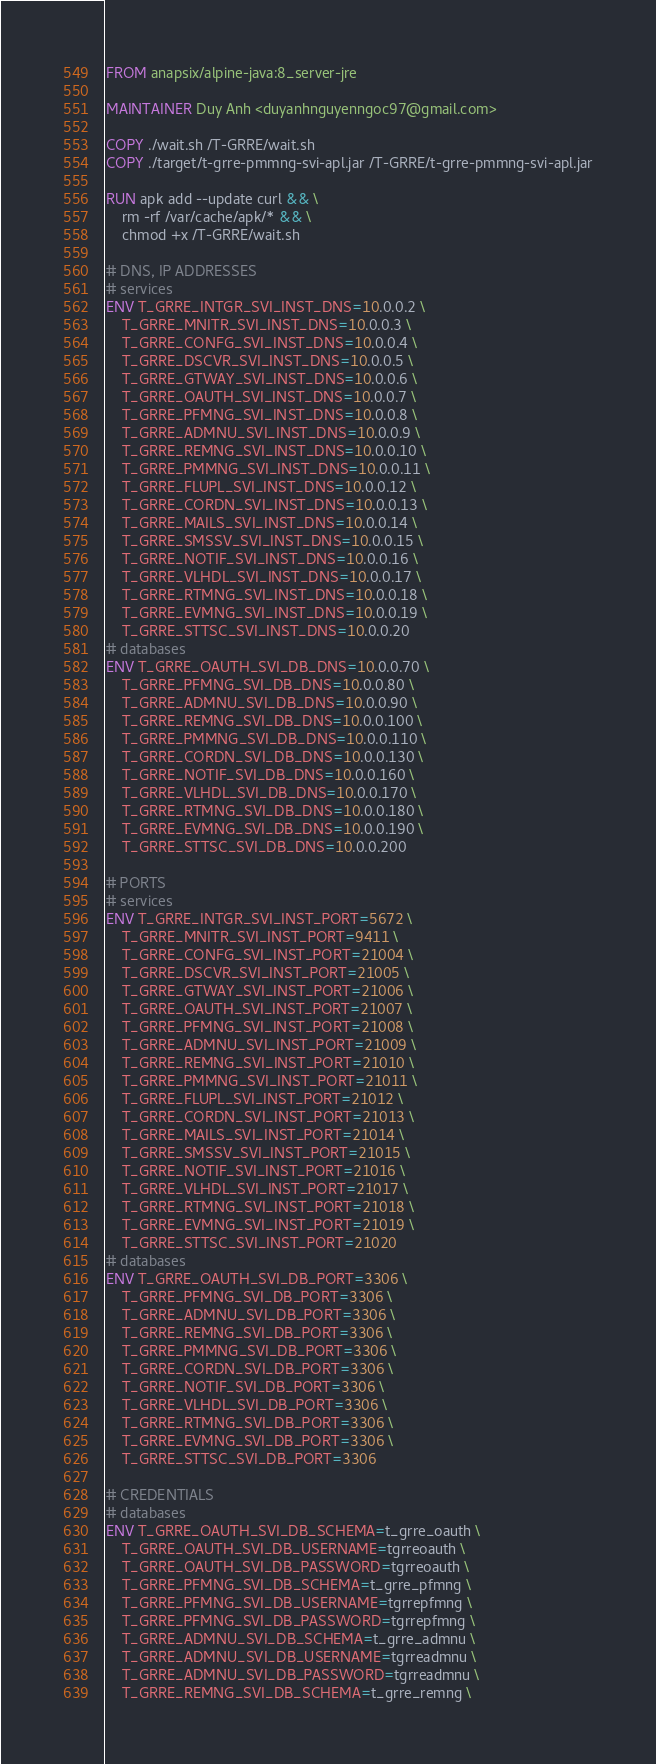<code> <loc_0><loc_0><loc_500><loc_500><_Dockerfile_>FROM anapsix/alpine-java:8_server-jre

MAINTAINER Duy Anh <duyanhnguyenngoc97@gmail.com>

COPY ./wait.sh /T-GRRE/wait.sh
COPY ./target/t-grre-pmmng-svi-apl.jar /T-GRRE/t-grre-pmmng-svi-apl.jar

RUN apk add --update curl && \
    rm -rf /var/cache/apk/* && \
    chmod +x /T-GRRE/wait.sh

# DNS, IP ADDRESSES
# services
ENV T_GRRE_INTGR_SVI_INST_DNS=10.0.0.2 \
    T_GRRE_MNITR_SVI_INST_DNS=10.0.0.3 \
    T_GRRE_CONFG_SVI_INST_DNS=10.0.0.4 \
    T_GRRE_DSCVR_SVI_INST_DNS=10.0.0.5 \
    T_GRRE_GTWAY_SVI_INST_DNS=10.0.0.6 \
    T_GRRE_OAUTH_SVI_INST_DNS=10.0.0.7 \
    T_GRRE_PFMNG_SVI_INST_DNS=10.0.0.8 \
    T_GRRE_ADMNU_SVI_INST_DNS=10.0.0.9 \
    T_GRRE_REMNG_SVI_INST_DNS=10.0.0.10 \
    T_GRRE_PMMNG_SVI_INST_DNS=10.0.0.11 \
    T_GRRE_FLUPL_SVI_INST_DNS=10.0.0.12 \
    T_GRRE_CORDN_SVI_INST_DNS=10.0.0.13 \
    T_GRRE_MAILS_SVI_INST_DNS=10.0.0.14 \
    T_GRRE_SMSSV_SVI_INST_DNS=10.0.0.15 \
    T_GRRE_NOTIF_SVI_INST_DNS=10.0.0.16 \
    T_GRRE_VLHDL_SVI_INST_DNS=10.0.0.17 \
    T_GRRE_RTMNG_SVI_INST_DNS=10.0.0.18 \
    T_GRRE_EVMNG_SVI_INST_DNS=10.0.0.19 \
    T_GRRE_STTSC_SVI_INST_DNS=10.0.0.20
# databases
ENV T_GRRE_OAUTH_SVI_DB_DNS=10.0.0.70 \
    T_GRRE_PFMNG_SVI_DB_DNS=10.0.0.80 \
    T_GRRE_ADMNU_SVI_DB_DNS=10.0.0.90 \
    T_GRRE_REMNG_SVI_DB_DNS=10.0.0.100 \
    T_GRRE_PMMNG_SVI_DB_DNS=10.0.0.110 \
    T_GRRE_CORDN_SVI_DB_DNS=10.0.0.130 \
    T_GRRE_NOTIF_SVI_DB_DNS=10.0.0.160 \
    T_GRRE_VLHDL_SVI_DB_DNS=10.0.0.170 \
    T_GRRE_RTMNG_SVI_DB_DNS=10.0.0.180 \
    T_GRRE_EVMNG_SVI_DB_DNS=10.0.0.190 \
    T_GRRE_STTSC_SVI_DB_DNS=10.0.0.200

# PORTS
# services
ENV T_GRRE_INTGR_SVI_INST_PORT=5672 \
    T_GRRE_MNITR_SVI_INST_PORT=9411 \
    T_GRRE_CONFG_SVI_INST_PORT=21004 \
    T_GRRE_DSCVR_SVI_INST_PORT=21005 \
    T_GRRE_GTWAY_SVI_INST_PORT=21006 \
    T_GRRE_OAUTH_SVI_INST_PORT=21007 \
    T_GRRE_PFMNG_SVI_INST_PORT=21008 \
    T_GRRE_ADMNU_SVI_INST_PORT=21009 \
    T_GRRE_REMNG_SVI_INST_PORT=21010 \
    T_GRRE_PMMNG_SVI_INST_PORT=21011 \
    T_GRRE_FLUPL_SVI_INST_PORT=21012 \
    T_GRRE_CORDN_SVI_INST_PORT=21013 \
    T_GRRE_MAILS_SVI_INST_PORT=21014 \
    T_GRRE_SMSSV_SVI_INST_PORT=21015 \
    T_GRRE_NOTIF_SVI_INST_PORT=21016 \
    T_GRRE_VLHDL_SVI_INST_PORT=21017 \
    T_GRRE_RTMNG_SVI_INST_PORT=21018 \
    T_GRRE_EVMNG_SVI_INST_PORT=21019 \
    T_GRRE_STTSC_SVI_INST_PORT=21020
# databases
ENV T_GRRE_OAUTH_SVI_DB_PORT=3306 \
    T_GRRE_PFMNG_SVI_DB_PORT=3306 \
    T_GRRE_ADMNU_SVI_DB_PORT=3306 \
    T_GRRE_REMNG_SVI_DB_PORT=3306 \
    T_GRRE_PMMNG_SVI_DB_PORT=3306 \
    T_GRRE_CORDN_SVI_DB_PORT=3306 \
    T_GRRE_NOTIF_SVI_DB_PORT=3306 \
    T_GRRE_VLHDL_SVI_DB_PORT=3306 \
    T_GRRE_RTMNG_SVI_DB_PORT=3306 \
    T_GRRE_EVMNG_SVI_DB_PORT=3306 \
    T_GRRE_STTSC_SVI_DB_PORT=3306

# CREDENTIALS
# databases
ENV T_GRRE_OAUTH_SVI_DB_SCHEMA=t_grre_oauth \
    T_GRRE_OAUTH_SVI_DB_USERNAME=tgrreoauth \
    T_GRRE_OAUTH_SVI_DB_PASSWORD=tgrreoauth \
    T_GRRE_PFMNG_SVI_DB_SCHEMA=t_grre_pfmng \
    T_GRRE_PFMNG_SVI_DB_USERNAME=tgrrepfmng \
    T_GRRE_PFMNG_SVI_DB_PASSWORD=tgrrepfmng \
    T_GRRE_ADMNU_SVI_DB_SCHEMA=t_grre_admnu \
    T_GRRE_ADMNU_SVI_DB_USERNAME=tgrreadmnu \
    T_GRRE_ADMNU_SVI_DB_PASSWORD=tgrreadmnu \
    T_GRRE_REMNG_SVI_DB_SCHEMA=t_grre_remng \</code> 